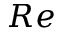Convert formula to latex. <formula><loc_0><loc_0><loc_500><loc_500>R e</formula> 